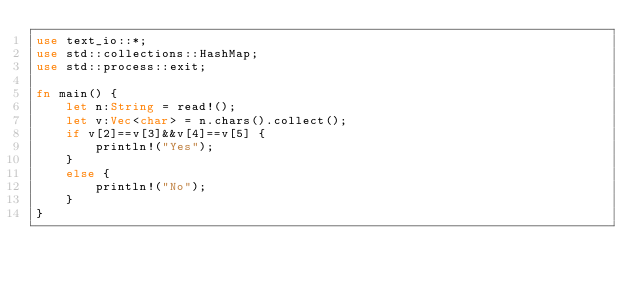<code> <loc_0><loc_0><loc_500><loc_500><_Rust_>use text_io::*;
use std::collections::HashMap;
use std::process::exit;

fn main() {
    let n:String = read!();
    let v:Vec<char> = n.chars().collect();
    if v[2]==v[3]&&v[4]==v[5] {
        println!("Yes");
    }
    else {
        println!("No");
    }
}</code> 